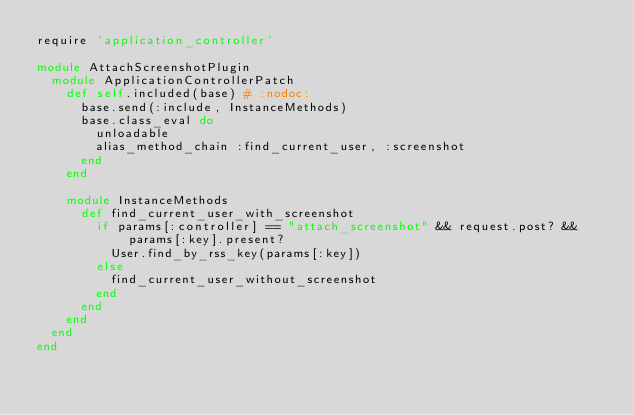<code> <loc_0><loc_0><loc_500><loc_500><_Ruby_>require 'application_controller'

module AttachScreenshotPlugin
  module ApplicationControllerPatch
    def self.included(base) # :nodoc:
      base.send(:include, InstanceMethods)
      base.class_eval do
        unloadable
        alias_method_chain :find_current_user, :screenshot
      end
    end

    module InstanceMethods
      def find_current_user_with_screenshot
        if params[:controller] == "attach_screenshot" && request.post? && params[:key].present?
          User.find_by_rss_key(params[:key])
        else
          find_current_user_without_screenshot
        end
      end
    end
  end
end
</code> 